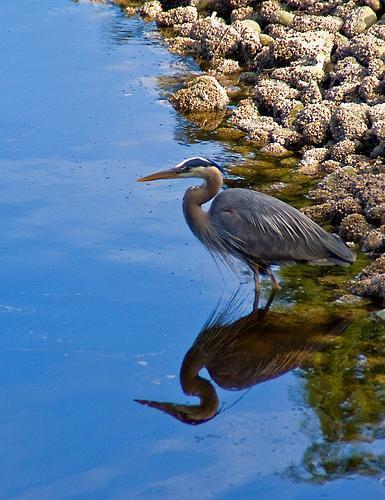How many birds are there?
Give a very brief answer. 1. 